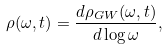Convert formula to latex. <formula><loc_0><loc_0><loc_500><loc_500>\rho ( \omega , t ) = \frac { d \rho _ { G W } ( \omega , t ) } { d \log { \omega } } ,</formula> 